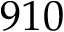<formula> <loc_0><loc_0><loc_500><loc_500>9 1 0</formula> 